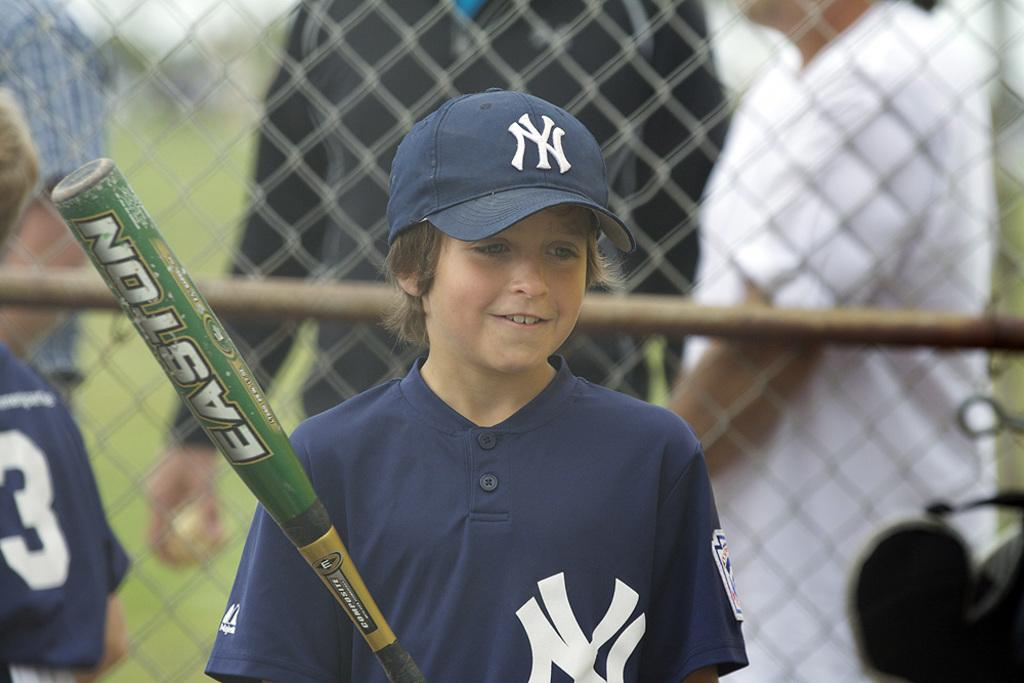<image>
Offer a succinct explanation of the picture presented. A boy is holding a bat with the brand name Easton. 